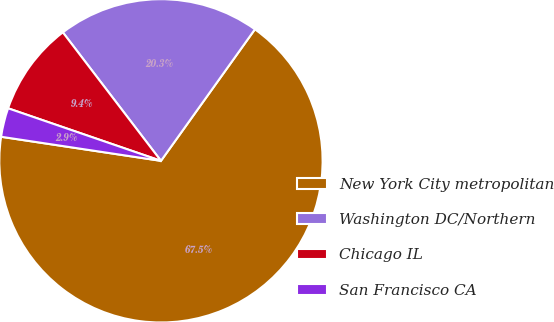Convert chart to OTSL. <chart><loc_0><loc_0><loc_500><loc_500><pie_chart><fcel>New York City metropolitan<fcel>Washington DC/Northern<fcel>Chicago IL<fcel>San Francisco CA<nl><fcel>67.5%<fcel>20.25%<fcel>9.35%<fcel>2.89%<nl></chart> 